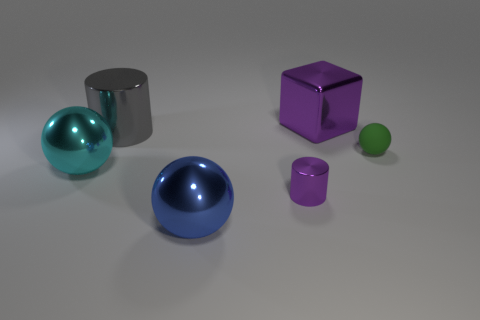Is there anything else that is the same shape as the big blue metallic object?
Make the answer very short. Yes. What is the color of the sphere to the right of the ball that is in front of the small purple object?
Provide a succinct answer. Green. How many green matte balls are there?
Your answer should be very brief. 1. What number of matte objects are either big yellow cylinders or large purple cubes?
Your answer should be compact. 0. What number of shiny objects are the same color as the tiny matte sphere?
Your answer should be very brief. 0. There is a ball that is on the right side of the big object behind the gray shiny object; what is it made of?
Your answer should be very brief. Rubber. What is the size of the purple cylinder?
Your answer should be compact. Small. What number of shiny balls have the same size as the cyan metallic thing?
Offer a terse response. 1. How many big blue shiny objects are the same shape as the large cyan thing?
Give a very brief answer. 1. Are there the same number of large objects in front of the gray metallic cylinder and blue metallic things?
Make the answer very short. No. 